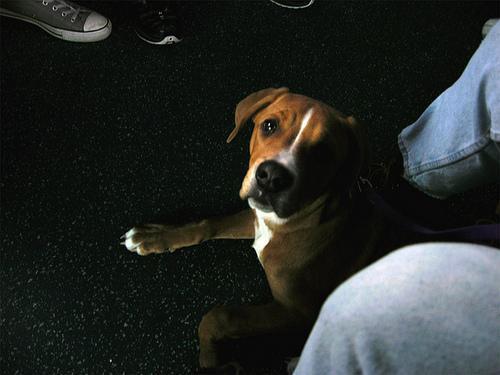How many dogs are there?
Give a very brief answer. 1. 